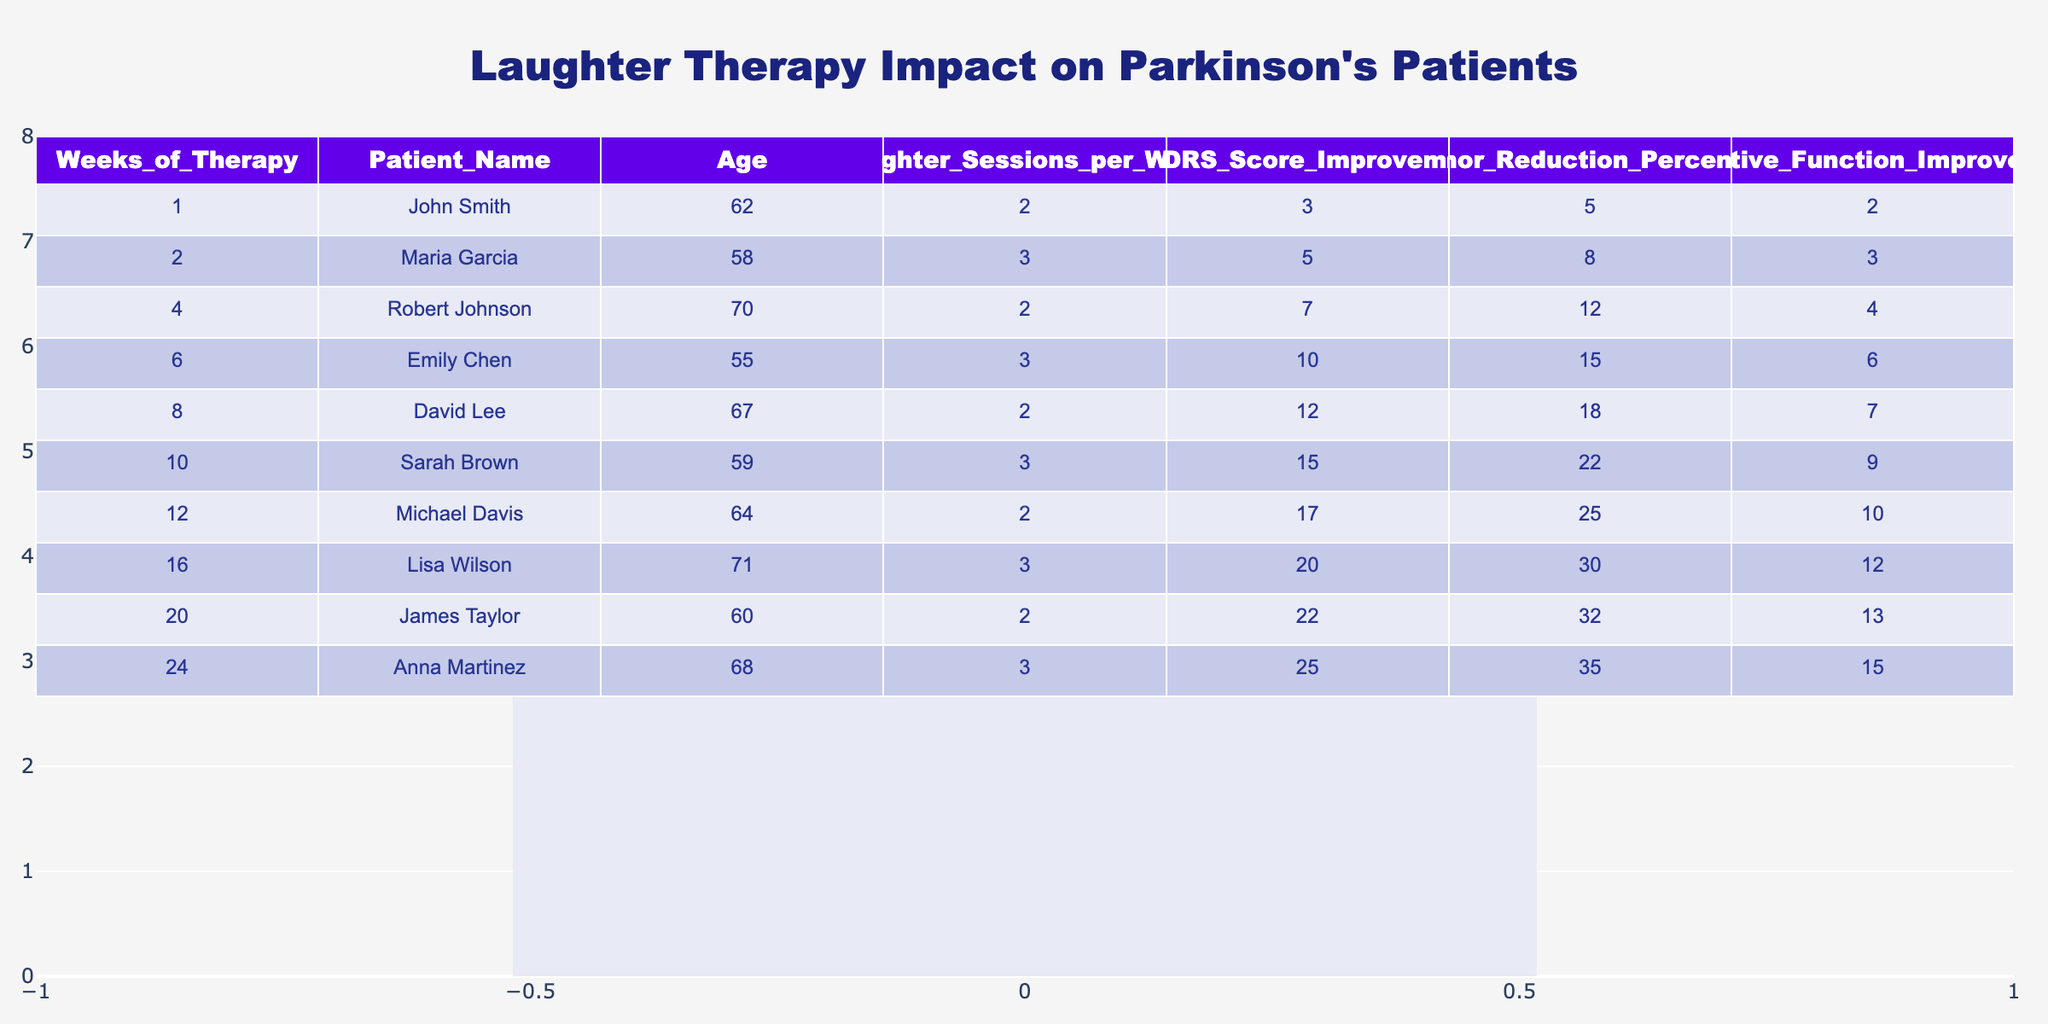What is the age of Sarah Brown? The table lists the age of each patient, and for Sarah Brown, it shows 59 years old.
Answer: 59 What is the UPDRS score improvement for David Lee? The table indicates that David Lee experienced a UPDRS score improvement of 12.
Answer: 12 Which patient had the highest tremor reduction percentage and what was that percentage? According to the table, Anna Martinez had the highest tremor reduction percentage at 35%.
Answer: 35% How many laughter sessions per week did Michael Davis have? The information in the table states that Michael Davis attended 2 laughter sessions per week.
Answer: 2 What is the total UPDRS score improvement for all patients? Adding all UPDRS score improvements together: 3 + 5 + 7 + 10 + 12 + 15 + 17 + 20 + 22 + 25 =  126.
Answer: 126 Is it true that all patients improved their cognitive function? The table shows that every patient has a positive number for cognitive function improvement, confirming that all improved.
Answer: Yes What is the average tremor reduction percentage for patients attending 3 laughter sessions per week? From the table, patients with 3 laughter sessions (Maria Garcia, Emily Chen, Sarah Brown, Lisa Wilson, Anna Martinez) have tremor reductions of 8, 15, 22, 30, and 35 respectively. The average is (8 + 15 + 22 + 30 + 35) / 5 = 22.
Answer: 22 How does the duration of therapy correlate with UPDRS score improvement? Analyzing the data, as the weeks of therapy increase, the UPDRS score improvement also increases, indicating a positive correlation.
Answer: Positive correlation What is the maximum improvement in cognitive function observed and which patient achieved it? The table indicates that Anna Martinez had the maximum improvement of 15 in cognitive function.
Answer: 15, Anna Martinez Calculate the difference in UPDRS score improvement between the youngest and oldest patients. The youngest patient is Emily Chen with an improvement of 10, and the oldest is Robert Johnson with 7. The difference is 10 - 7 = 3.
Answer: 3 